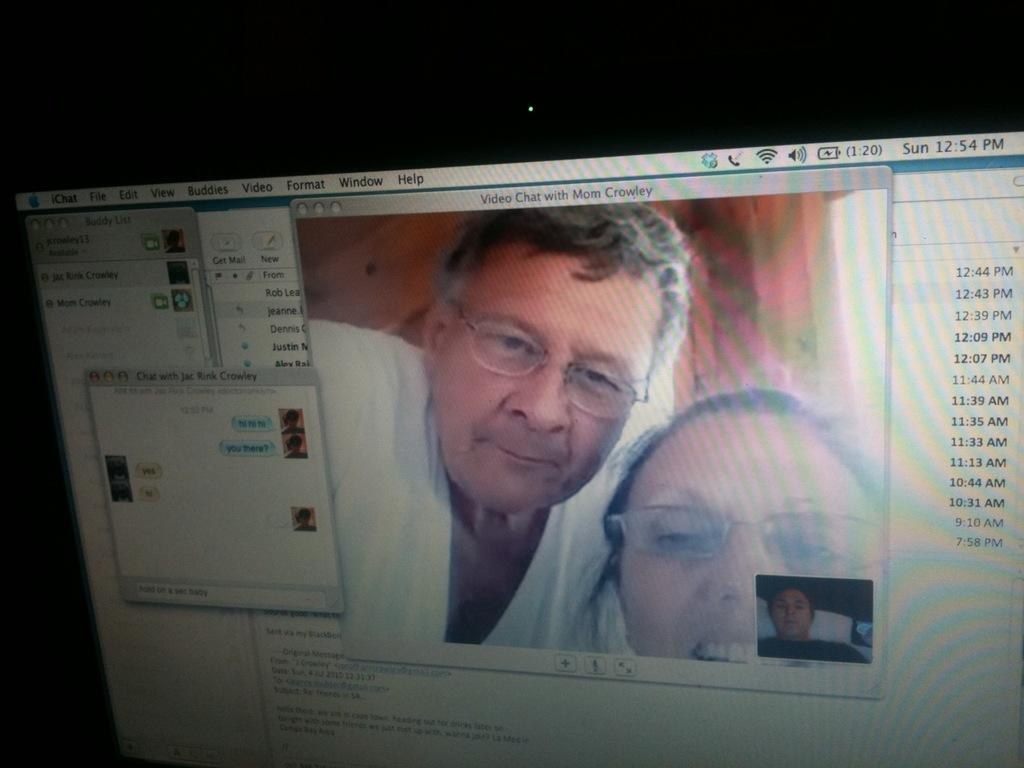What electronic device is present in the image? There is a computer in the image. What is the status of the computer's screen? The computer's screen is turned on. What is displayed on the screen? There is a man and woman picture on the screen, along with dates and other tabs or elements. What type of cake is being served at the event shown on the computer screen? There is no event or cake shown on the computer screen; it displays a man and woman picture, dates, and other tabs or elements. 